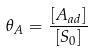Convert formula to latex. <formula><loc_0><loc_0><loc_500><loc_500>\theta _ { A } = \frac { [ A _ { a d } ] } { [ S _ { 0 } ] }</formula> 